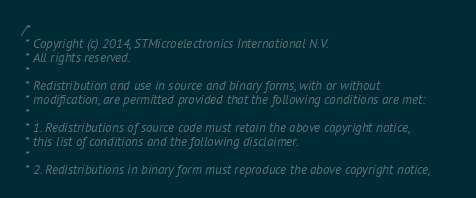<code> <loc_0><loc_0><loc_500><loc_500><_C_>/*
 * Copyright (c) 2014, STMicroelectronics International N.V.
 * All rights reserved.
 *
 * Redistribution and use in source and binary forms, with or without
 * modification, are permitted provided that the following conditions are met:
 *
 * 1. Redistributions of source code must retain the above copyright notice,
 * this list of conditions and the following disclaimer.
 *
 * 2. Redistributions in binary form must reproduce the above copyright notice,</code> 